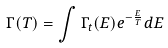Convert formula to latex. <formula><loc_0><loc_0><loc_500><loc_500>\Gamma ( T ) = \int \Gamma _ { t } ( E ) e ^ { - \frac { E } { T } } d E</formula> 